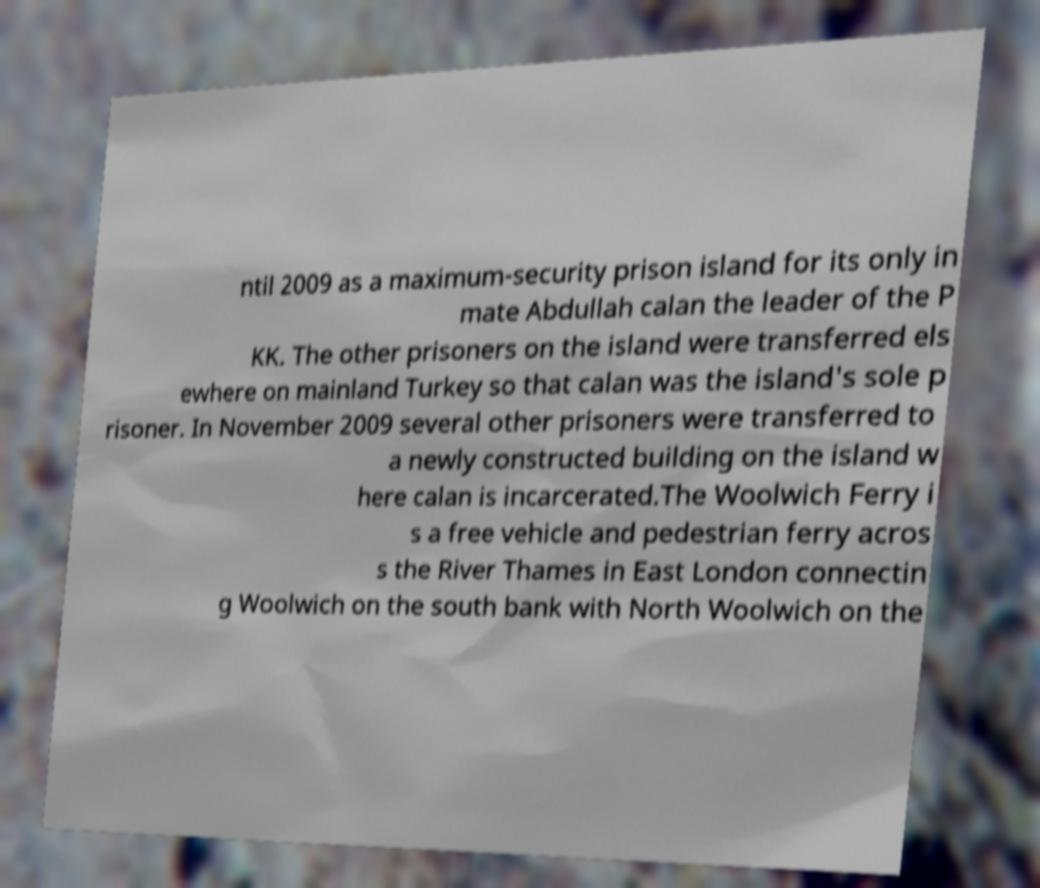What messages or text are displayed in this image? I need them in a readable, typed format. ntil 2009 as a maximum-security prison island for its only in mate Abdullah calan the leader of the P KK. The other prisoners on the island were transferred els ewhere on mainland Turkey so that calan was the island's sole p risoner. In November 2009 several other prisoners were transferred to a newly constructed building on the island w here calan is incarcerated.The Woolwich Ferry i s a free vehicle and pedestrian ferry acros s the River Thames in East London connectin g Woolwich on the south bank with North Woolwich on the 